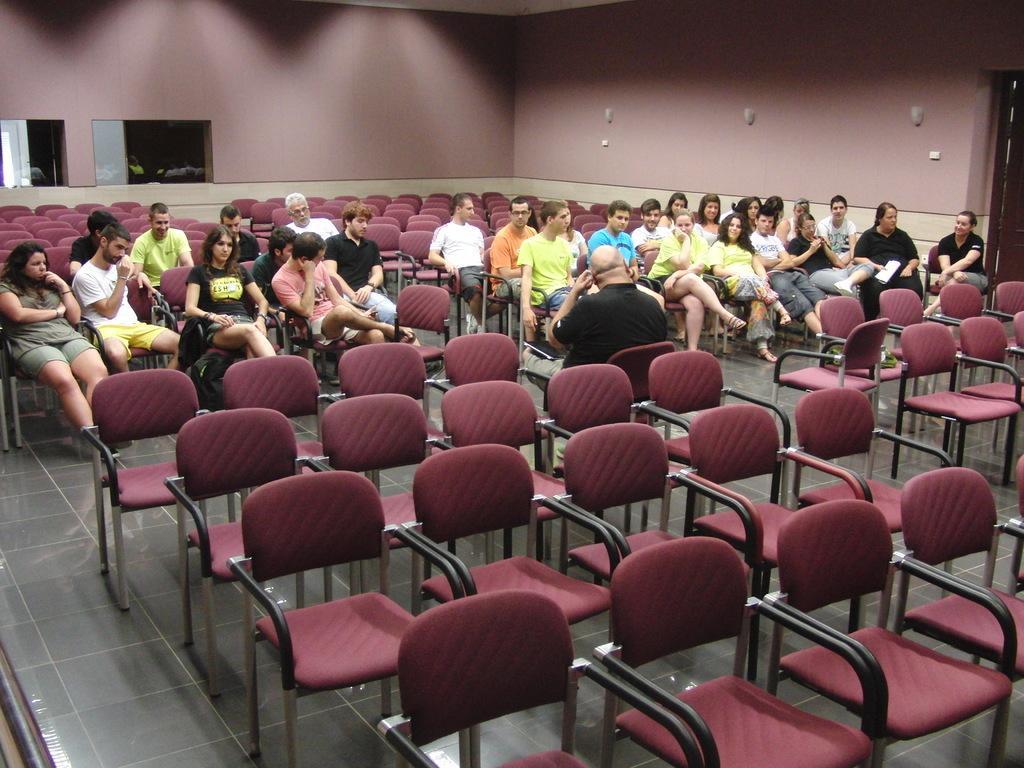How would you summarize this image in a sentence or two? In this picture there are group of people those who are sitting on the chairs, there are two windows at the left side of the image and there is a door at the right side of the image. 